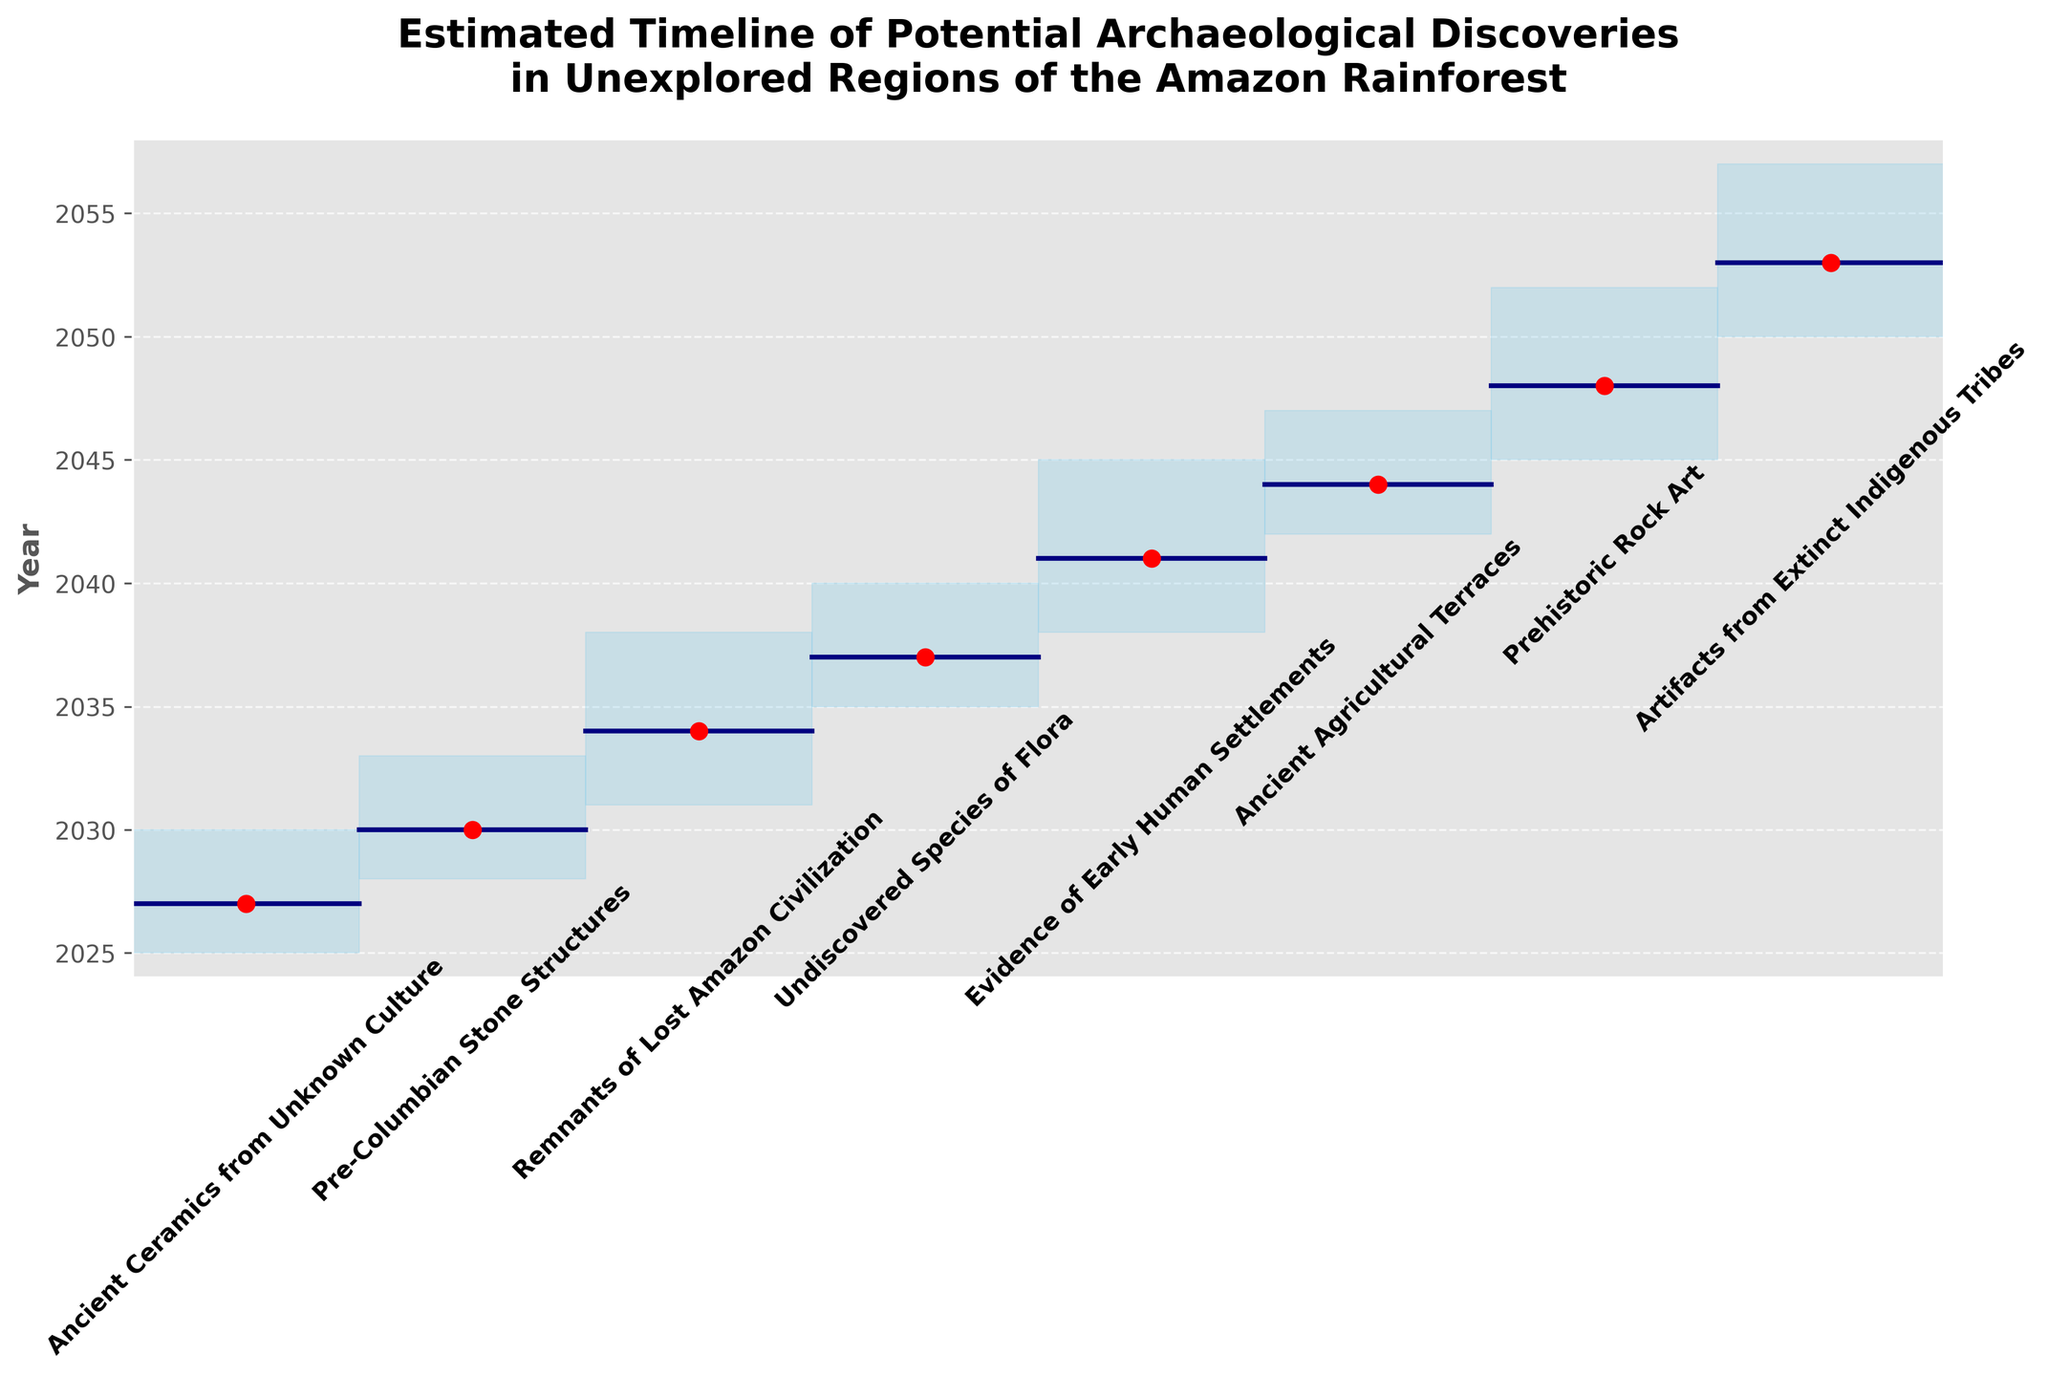What is the title of the figure? The title is at the top of the figure, providing an overview of its content.
Answer: Estimated Timeline of Potential Archaeological Discoveries in Unexplored Regions of the Amazon Rainforest How many archaeological discoveries are listed on the figure? Count the number of unique archaeological discoveries mentioned along the x-axis.
Answer: 8 Which discovery is projected to be found earliest according to the mid estimate? Identify the discovery with the earliest mid estimate year from the y-axis.
Answer: Ancient Ceramics from Unknown Culture Which discovery has the widest range between its low and high estimates? Calculate the differences between low and high estimates for each discovery and compare them. The discovery with the largest difference is the answer.
Answer: Evidence of Early Human Settlements When are Pre-Columbian Stone Structures expected to be discovered according to the high estimate? Locate Pre-Columbian Stone Structures on the x-axis and find the corresponding high estimate year on the y-axis.
Answer: 2033 What is the estimated mid-discovery year for the Artifacts from Extinct Indigenous Tribes? Locate Artifacts from Extinct Indigenous Tribes on the x-axis and find the corresponding mid estimate year on the y-axis.
Answer: 2053 Which discovery happens right after remnants of a lost Amazon civilization according to the timeline? Look at the chronological order of the mid estimates and identify the discovery that follows the Remnants of Lost Amazon Civilization.
Answer: Undiscovered Species of Flora What is the difference in years between the low and high estimates of discovering Ancient Agricultural Terraces? Identify the low and high estimates for Ancient Agricultural Terraces and subtract the low estimate year from the high estimate year.
Answer: 5 years How do the mid estimates of Ancient Ceramics from Unknown Culture and Evidence of Early Human Settlements compare? Compare the mid estimate years for both discoveries to see which is earlier or later.
Answer: Ancient Ceramics from Unknown Culture is earlier Which type of finding is expected to occur closer to 2040, Prehistoric Rock Art or Ancient Agricultural Terraces? Compare the mid estimate years of Prehistoric Rock Art and Ancient Agricultural Terraces to determine which is closer to 2040.
Answer: Ancient Agricultural Terraces 